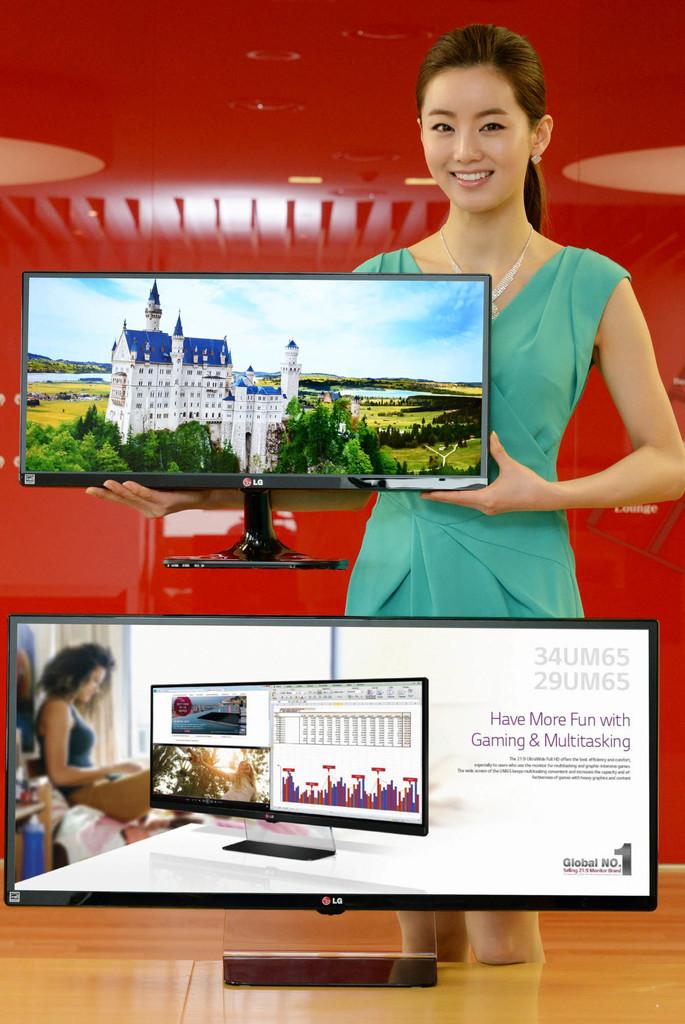What is one of the things the product can be used for?
Give a very brief answer. Gaming. 